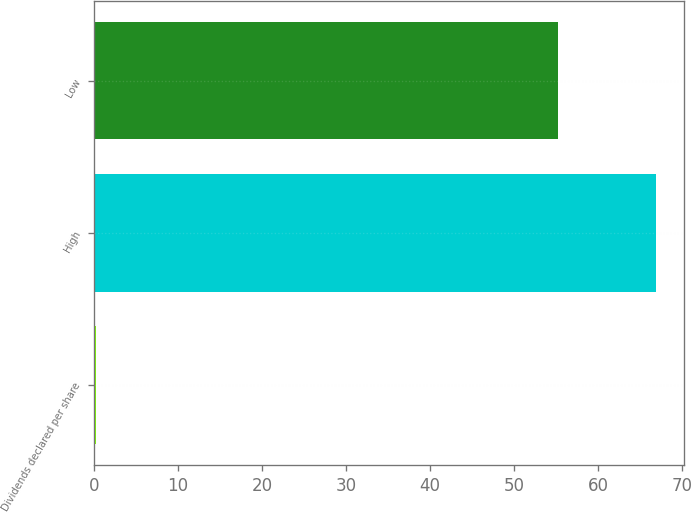Convert chart to OTSL. <chart><loc_0><loc_0><loc_500><loc_500><bar_chart><fcel>Dividends declared per share<fcel>High<fcel>Low<nl><fcel>0.27<fcel>66.92<fcel>55.24<nl></chart> 